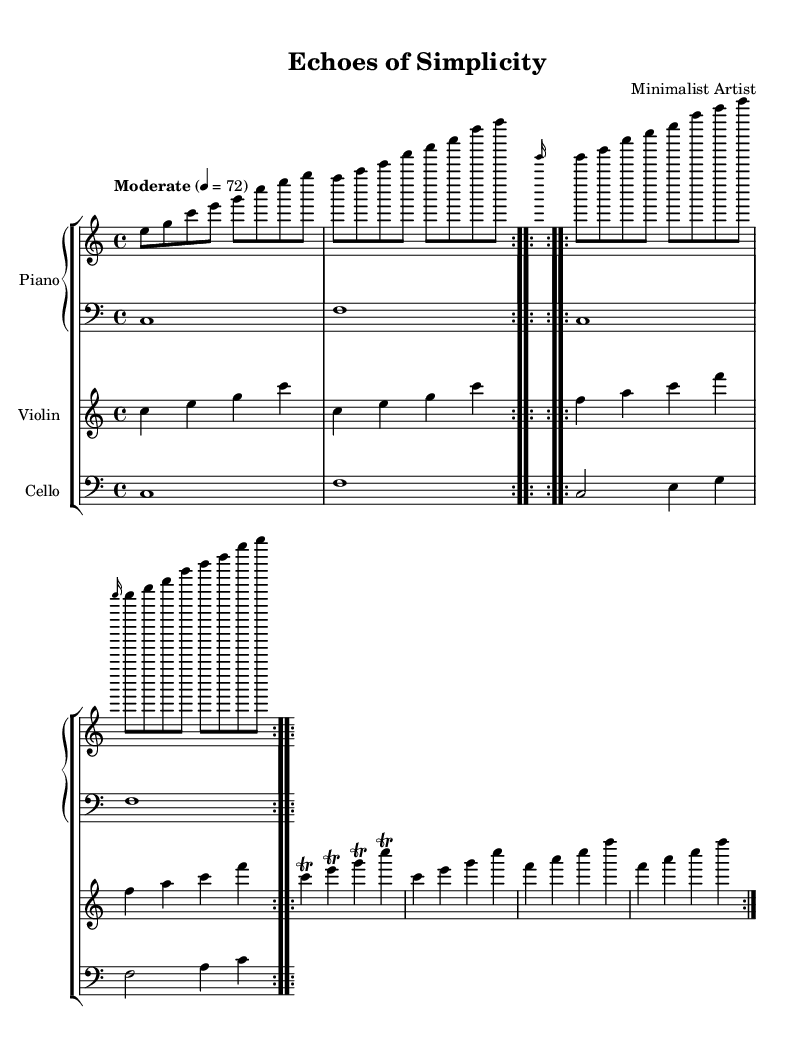What is the key signature of this music? The key signature is indicated at the beginning of the sheet music. It shows no sharps or flats, which is characteristic of C major.
Answer: C major What is the time signature of this piece? The time signature is displayed at the beginning of the sheet music, showing that each measure has four beats, indicated as 4/4.
Answer: 4/4 What is the tempo marking for this composition? The tempo marking indicates how fast the music should be played, specifically denoted as "Moderate" with a metronome marking of 72 beats per minute.
Answer: Moderate 72 How many times do the repeating sections occur in the piano right hand? By looking at the repeat symbols in the score, the repeating sections are indicated to occur two times before moving on to the next section.
Answer: 2 What instruments are featured in this composition? The instruments are indicated in the score, which includes Piano, Violin, and Cello, shown clearly at the beginning of each staff.
Answer: Piano, Violin, Cello How is the violin part constructed in the second section? The violin part in the second section contains trills on each note, showing a decorative embellishment that adds complexity to the original melody.
Answer: Trills 